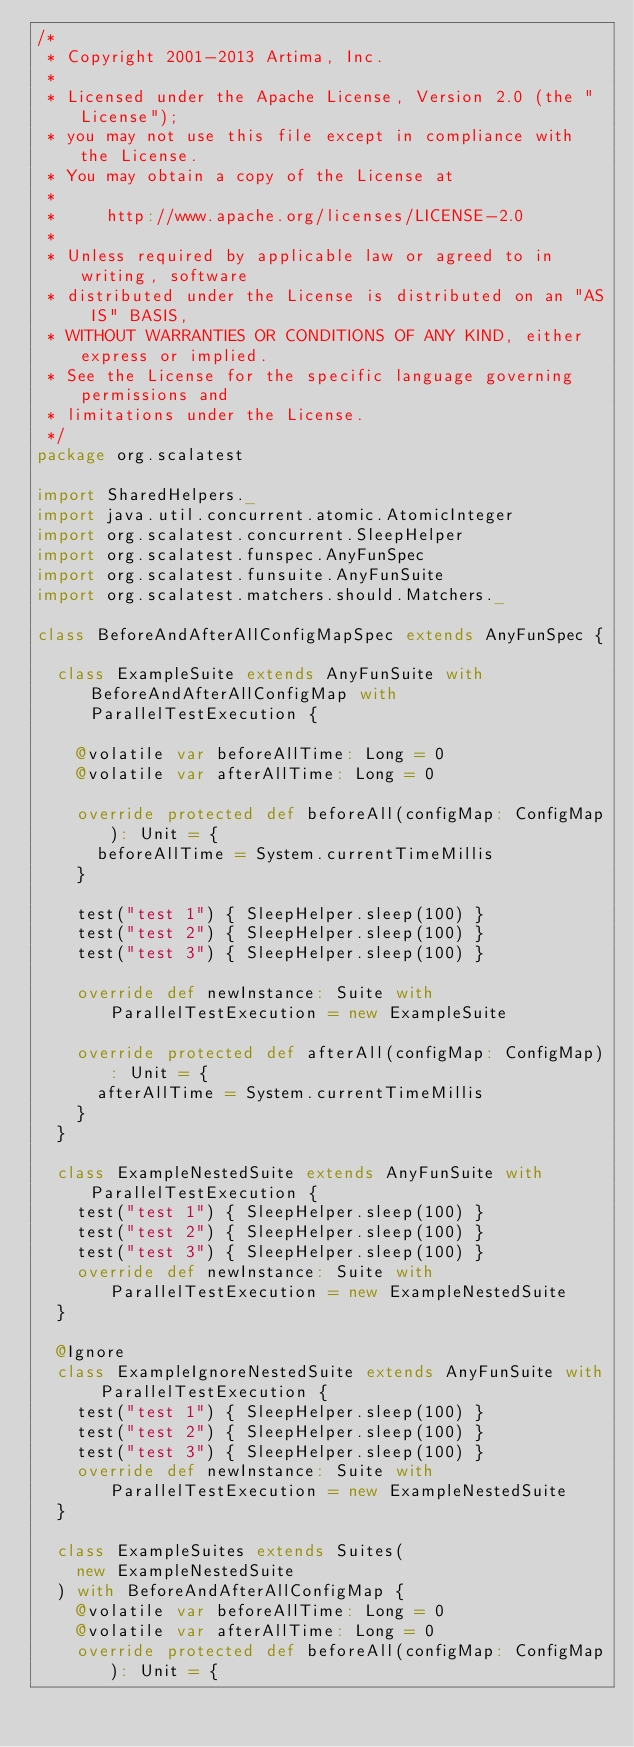<code> <loc_0><loc_0><loc_500><loc_500><_Scala_>/*
 * Copyright 2001-2013 Artima, Inc.
 *
 * Licensed under the Apache License, Version 2.0 (the "License");
 * you may not use this file except in compliance with the License.
 * You may obtain a copy of the License at
 *
 *     http://www.apache.org/licenses/LICENSE-2.0
 *
 * Unless required by applicable law or agreed to in writing, software
 * distributed under the License is distributed on an "AS IS" BASIS,
 * WITHOUT WARRANTIES OR CONDITIONS OF ANY KIND, either express or implied.
 * See the License for the specific language governing permissions and
 * limitations under the License.
 */
package org.scalatest

import SharedHelpers._
import java.util.concurrent.atomic.AtomicInteger
import org.scalatest.concurrent.SleepHelper
import org.scalatest.funspec.AnyFunSpec
import org.scalatest.funsuite.AnyFunSuite
import org.scalatest.matchers.should.Matchers._

class BeforeAndAfterAllConfigMapSpec extends AnyFunSpec {
  
  class ExampleSuite extends AnyFunSuite with BeforeAndAfterAllConfigMap with ParallelTestExecution {
    
    @volatile var beforeAllTime: Long = 0
    @volatile var afterAllTime: Long = 0
    
    override protected def beforeAll(configMap: ConfigMap): Unit = {
      beforeAllTime = System.currentTimeMillis
    }
    
    test("test 1") { SleepHelper.sleep(100) }
    test("test 2") { SleepHelper.sleep(100) }
    test("test 3") { SleepHelper.sleep(100) }
    
    override def newInstance: Suite with ParallelTestExecution = new ExampleSuite
    
    override protected def afterAll(configMap: ConfigMap): Unit = {
      afterAllTime = System.currentTimeMillis
    }
  }
  
  class ExampleNestedSuite extends AnyFunSuite with ParallelTestExecution {
    test("test 1") { SleepHelper.sleep(100) }
    test("test 2") { SleepHelper.sleep(100) }
    test("test 3") { SleepHelper.sleep(100) }
    override def newInstance: Suite with ParallelTestExecution = new ExampleNestedSuite
  }
  
  @Ignore
  class ExampleIgnoreNestedSuite extends AnyFunSuite with ParallelTestExecution {
    test("test 1") { SleepHelper.sleep(100) }
    test("test 2") { SleepHelper.sleep(100) }
    test("test 3") { SleepHelper.sleep(100) }
    override def newInstance: Suite with ParallelTestExecution = new ExampleNestedSuite
  }
  
  class ExampleSuites extends Suites(
    new ExampleNestedSuite
  ) with BeforeAndAfterAllConfigMap { 
    @volatile var beforeAllTime: Long = 0
    @volatile var afterAllTime: Long = 0
    override protected def beforeAll(configMap: ConfigMap): Unit = {</code> 